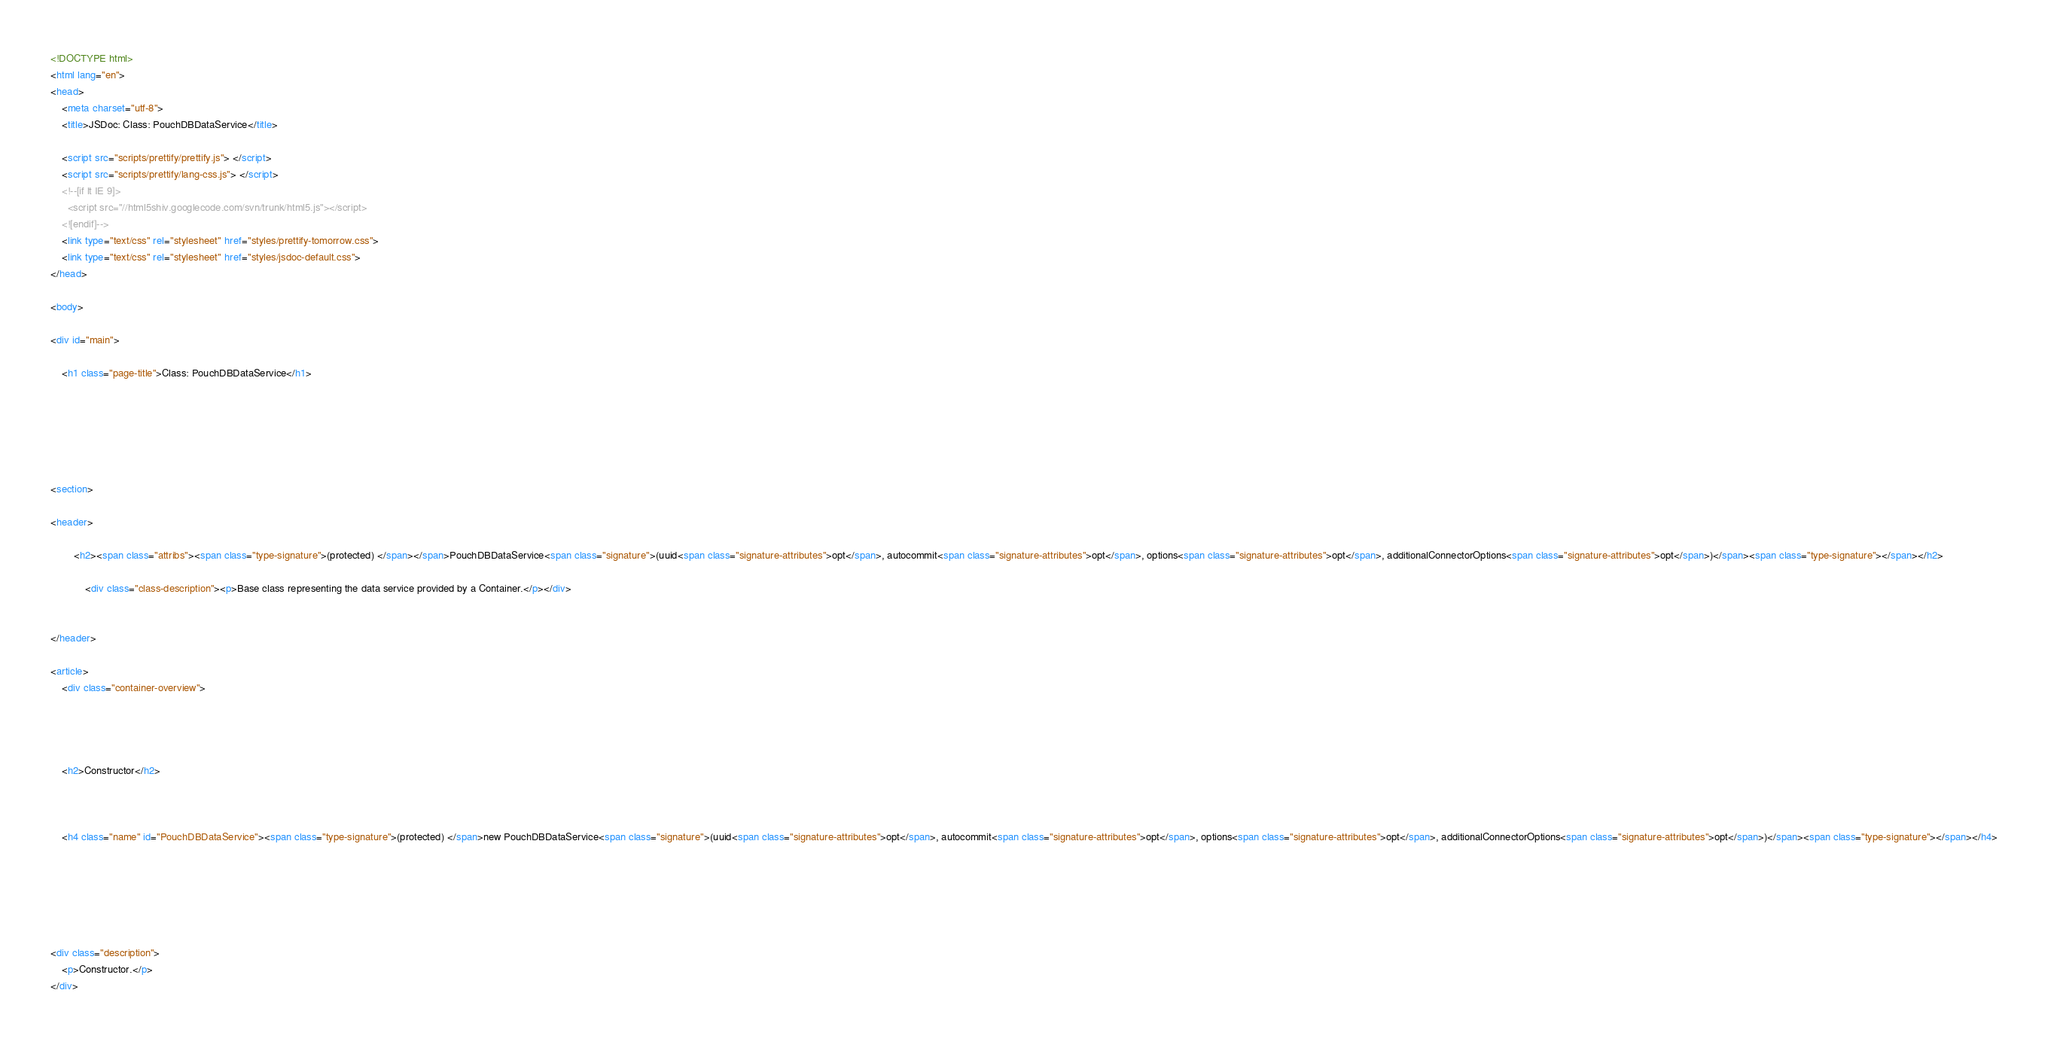Convert code to text. <code><loc_0><loc_0><loc_500><loc_500><_HTML_><!DOCTYPE html>
<html lang="en">
<head>
    <meta charset="utf-8">
    <title>JSDoc: Class: PouchDBDataService</title>

    <script src="scripts/prettify/prettify.js"> </script>
    <script src="scripts/prettify/lang-css.js"> </script>
    <!--[if lt IE 9]>
      <script src="//html5shiv.googlecode.com/svn/trunk/html5.js"></script>
    <![endif]-->
    <link type="text/css" rel="stylesheet" href="styles/prettify-tomorrow.css">
    <link type="text/css" rel="stylesheet" href="styles/jsdoc-default.css">
</head>

<body>

<div id="main">

    <h1 class="page-title">Class: PouchDBDataService</h1>

    




<section>

<header>
    
        <h2><span class="attribs"><span class="type-signature">(protected) </span></span>PouchDBDataService<span class="signature">(uuid<span class="signature-attributes">opt</span>, autocommit<span class="signature-attributes">opt</span>, options<span class="signature-attributes">opt</span>, additionalConnectorOptions<span class="signature-attributes">opt</span>)</span><span class="type-signature"></span></h2>
        
            <div class="class-description"><p>Base class representing the data service provided by a Container.</p></div>
        
    
</header>

<article>
    <div class="container-overview">
    
        

    
    <h2>Constructor</h2>
    

    
    <h4 class="name" id="PouchDBDataService"><span class="type-signature">(protected) </span>new PouchDBDataService<span class="signature">(uuid<span class="signature-attributes">opt</span>, autocommit<span class="signature-attributes">opt</span>, options<span class="signature-attributes">opt</span>, additionalConnectorOptions<span class="signature-attributes">opt</span>)</span><span class="type-signature"></span></h4>
    

    



<div class="description">
    <p>Constructor.</p>
</div>








</code> 